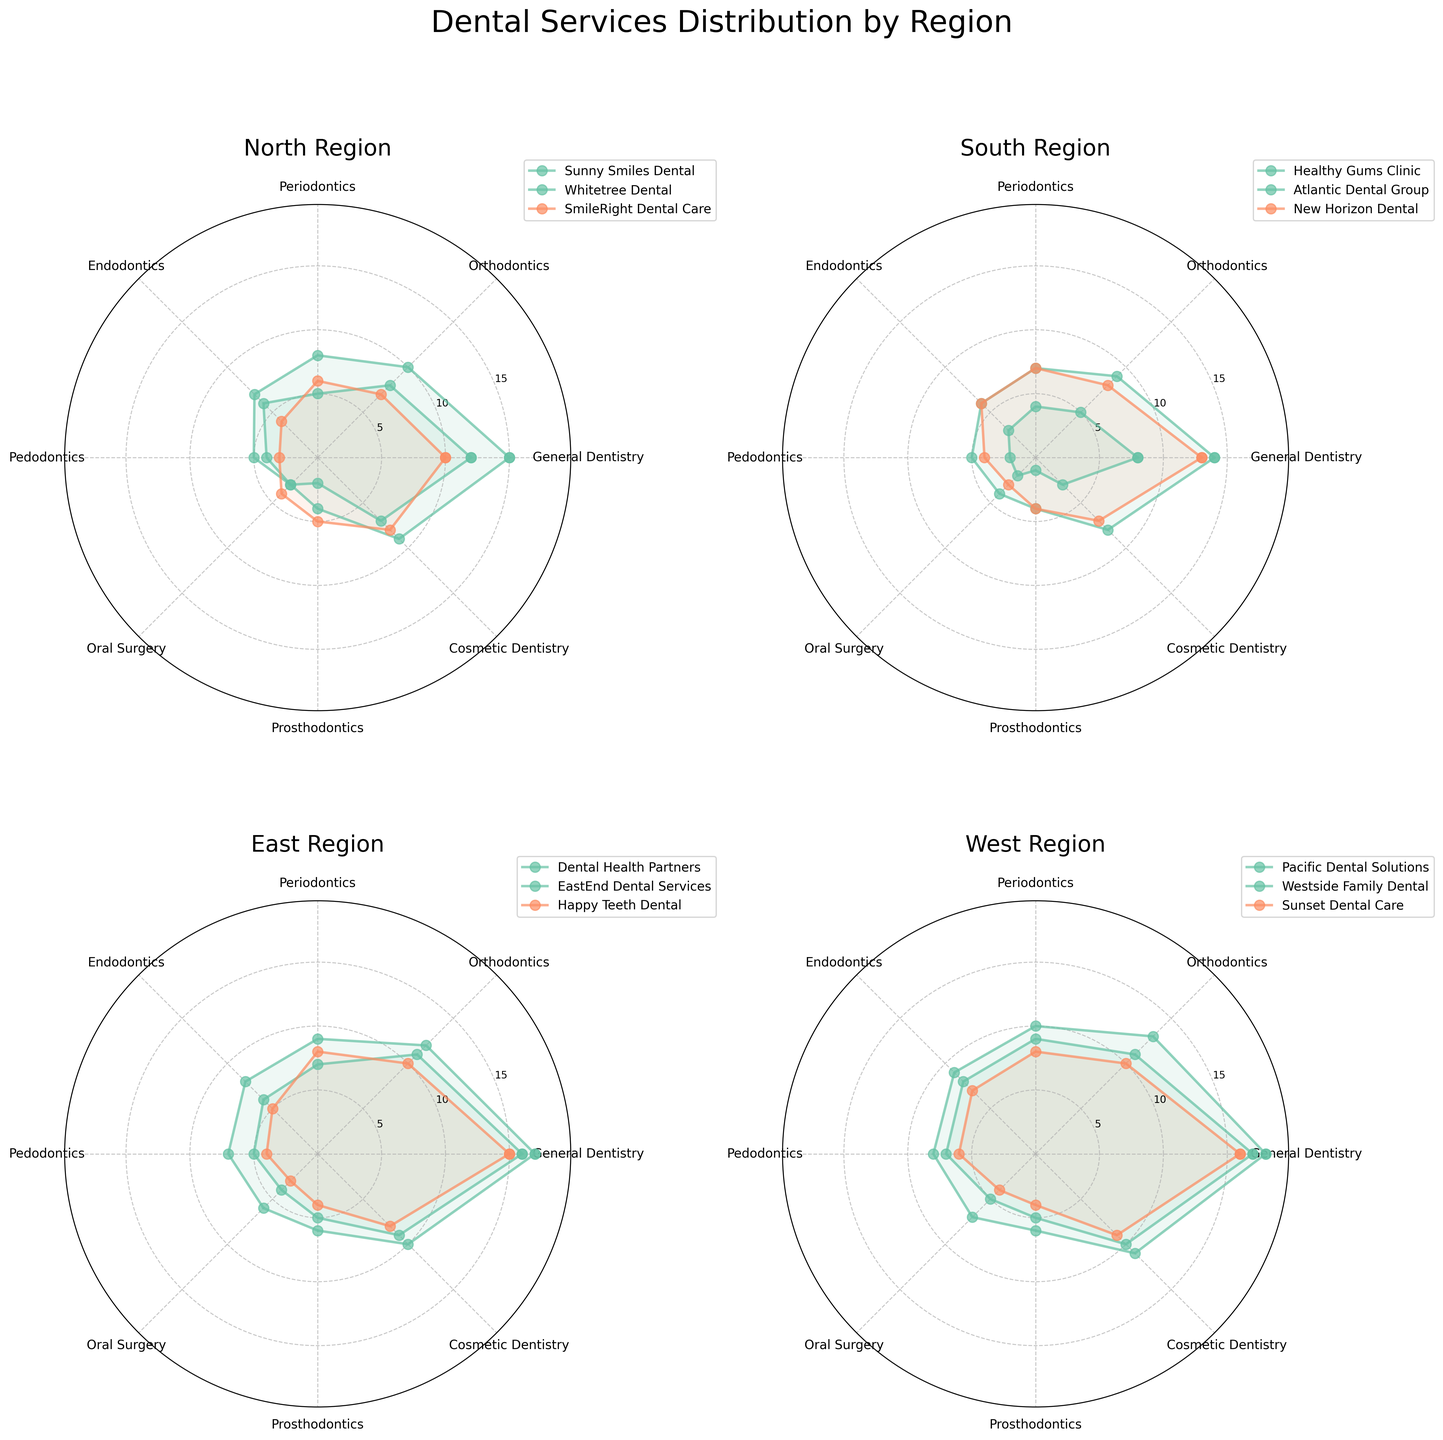What's the title of the figure? The title of the figure is prominently placed above the subplots, providing a summary of the data presented.
Answer: Dental Services Distribution by Region Which region has the highest maximum value for General Dentistry? From the subplot of each region, observe the peak value for General Dentistry section in each plot. The West region shows a maximum value of 18 for General Dentistry, being the highest among all regions.
Answer: West Compare the service offerings between Pacific Dental Solutions and Westside Family Dental in the West region. Locate the rose chart for the West region, then compare the lines and filled areas representing Pacific Dental Solutions and Westside Family Dental. Pacific Dental Solutions offers higher values across most services compared to Westside Family Dental, with notable differences in services like General Dentistry and Endodontics.
Answer: Pacific Dental Solutions has higher values in most services What is the average value of Endodontics services offered by clinics in the South region? Sum the Endodontics values for the three clinics (3 + 6 + 6 = 15) and divide by the number of clinics (3), giving an average of 5.
Answer: 5 How do the service offerings for Cosmetic Dentistry compare among clinics in the North region? Look at the Cosmetic Dentistry section for each clinic in the North region. The values are: Sunny Smiles Dental (7), Whitetree Dental (9), SmileRight Dental Care (8). Whitetree Dental offers the highest, followed by SmileRight Dental Care and Sunny Smiles Dental.
Answer: Whitetree Dental offers the most Which region has the most balanced service offerings across different services? Identify the regions with similar radar chart areas for different services. The North and South regions show more uniform smaller areas than the East and West, which have larger variances. Based on this balance, the North and South regions show more balance in service offerings.
Answer: North and South In the East region, which clinic has the most varied offerings across different dental services? Examine the rose chart for the East region, focusing on the spread of values for each clinic. Dental Health Partners shows the widest range from lower to higher values, indicating it has the most varied offerings.
Answer: Dental Health Partners Which clinic in the North region has the largest offering in Orthodontics? Look at the Orthodontics section in the North region's subplot. Whitetree Dental provides the highest value at 10.
Answer: Whitetree Dental How does Happy Teeth Dental's Pedodontics offerings compare to other clinics in the East region? In the East region's subplot, check the Pedodontics values. Happy Teeth Dental has a value of 4, which is lower than Dental Health Partners with 7, and EastEnd Dental Services with 5, placing Happy Teeth Dental with the lowest Pedodontics offerings.
Answer: Happy Teeth Dental offers the least 